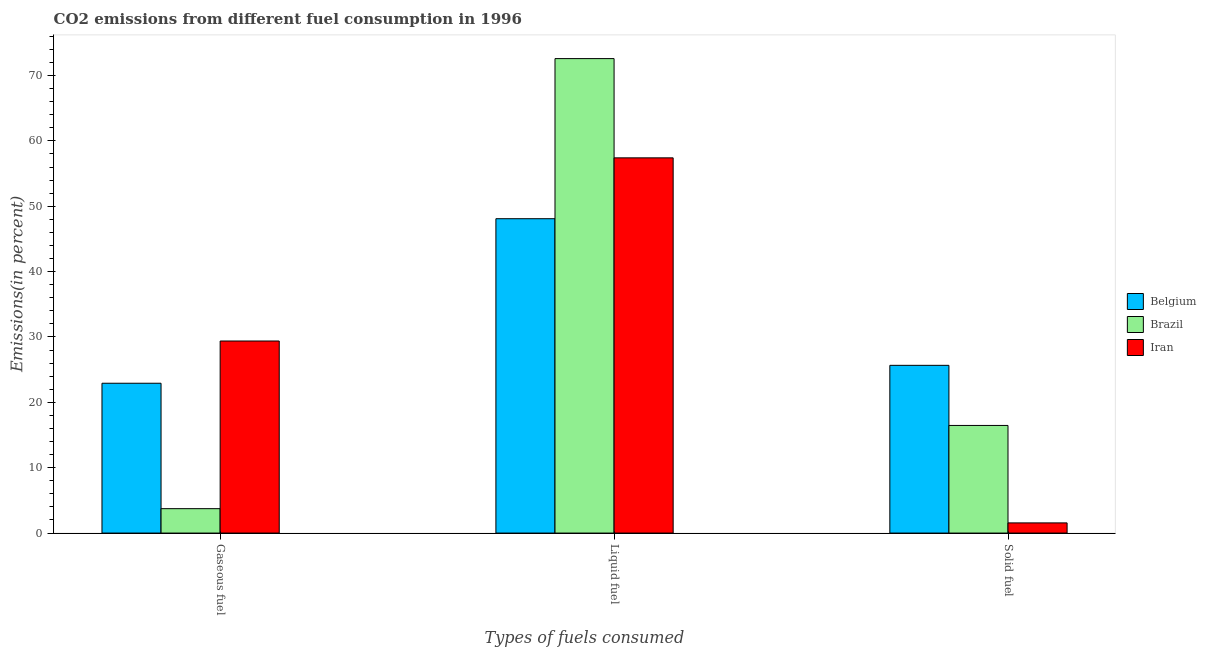How many different coloured bars are there?
Ensure brevity in your answer.  3. How many groups of bars are there?
Provide a succinct answer. 3. Are the number of bars on each tick of the X-axis equal?
Keep it short and to the point. Yes. How many bars are there on the 2nd tick from the left?
Ensure brevity in your answer.  3. What is the label of the 3rd group of bars from the left?
Ensure brevity in your answer.  Solid fuel. What is the percentage of solid fuel emission in Iran?
Offer a terse response. 1.56. Across all countries, what is the maximum percentage of solid fuel emission?
Provide a succinct answer. 25.66. Across all countries, what is the minimum percentage of gaseous fuel emission?
Provide a succinct answer. 3.73. In which country was the percentage of liquid fuel emission maximum?
Provide a short and direct response. Brazil. In which country was the percentage of solid fuel emission minimum?
Your answer should be very brief. Iran. What is the total percentage of liquid fuel emission in the graph?
Provide a short and direct response. 178.09. What is the difference between the percentage of solid fuel emission in Brazil and that in Belgium?
Give a very brief answer. -9.2. What is the difference between the percentage of gaseous fuel emission in Belgium and the percentage of liquid fuel emission in Brazil?
Make the answer very short. -49.67. What is the average percentage of liquid fuel emission per country?
Provide a succinct answer. 59.36. What is the difference between the percentage of gaseous fuel emission and percentage of liquid fuel emission in Brazil?
Provide a succinct answer. -68.86. In how many countries, is the percentage of gaseous fuel emission greater than 42 %?
Offer a terse response. 0. What is the ratio of the percentage of gaseous fuel emission in Brazil to that in Belgium?
Keep it short and to the point. 0.16. Is the percentage of liquid fuel emission in Belgium less than that in Brazil?
Ensure brevity in your answer.  Yes. Is the difference between the percentage of gaseous fuel emission in Brazil and Belgium greater than the difference between the percentage of liquid fuel emission in Brazil and Belgium?
Offer a very short reply. No. What is the difference between the highest and the second highest percentage of liquid fuel emission?
Offer a very short reply. 15.19. What is the difference between the highest and the lowest percentage of gaseous fuel emission?
Provide a succinct answer. 25.65. Is it the case that in every country, the sum of the percentage of gaseous fuel emission and percentage of liquid fuel emission is greater than the percentage of solid fuel emission?
Provide a short and direct response. Yes. How many countries are there in the graph?
Make the answer very short. 3. Are the values on the major ticks of Y-axis written in scientific E-notation?
Give a very brief answer. No. Where does the legend appear in the graph?
Offer a terse response. Center right. How many legend labels are there?
Provide a short and direct response. 3. How are the legend labels stacked?
Offer a terse response. Vertical. What is the title of the graph?
Your answer should be compact. CO2 emissions from different fuel consumption in 1996. Does "Latvia" appear as one of the legend labels in the graph?
Your answer should be compact. No. What is the label or title of the X-axis?
Keep it short and to the point. Types of fuels consumed. What is the label or title of the Y-axis?
Give a very brief answer. Emissions(in percent). What is the Emissions(in percent) of Belgium in Gaseous fuel?
Offer a very short reply. 22.92. What is the Emissions(in percent) in Brazil in Gaseous fuel?
Your response must be concise. 3.73. What is the Emissions(in percent) of Iran in Gaseous fuel?
Your answer should be very brief. 29.38. What is the Emissions(in percent) in Belgium in Liquid fuel?
Keep it short and to the point. 48.09. What is the Emissions(in percent) of Brazil in Liquid fuel?
Make the answer very short. 72.59. What is the Emissions(in percent) in Iran in Liquid fuel?
Provide a succinct answer. 57.4. What is the Emissions(in percent) of Belgium in Solid fuel?
Provide a succinct answer. 25.66. What is the Emissions(in percent) in Brazil in Solid fuel?
Offer a terse response. 16.47. What is the Emissions(in percent) of Iran in Solid fuel?
Your response must be concise. 1.56. Across all Types of fuels consumed, what is the maximum Emissions(in percent) in Belgium?
Your answer should be compact. 48.09. Across all Types of fuels consumed, what is the maximum Emissions(in percent) in Brazil?
Your answer should be very brief. 72.59. Across all Types of fuels consumed, what is the maximum Emissions(in percent) of Iran?
Keep it short and to the point. 57.4. Across all Types of fuels consumed, what is the minimum Emissions(in percent) of Belgium?
Your answer should be very brief. 22.92. Across all Types of fuels consumed, what is the minimum Emissions(in percent) of Brazil?
Provide a short and direct response. 3.73. Across all Types of fuels consumed, what is the minimum Emissions(in percent) of Iran?
Offer a terse response. 1.56. What is the total Emissions(in percent) in Belgium in the graph?
Provide a succinct answer. 96.68. What is the total Emissions(in percent) of Brazil in the graph?
Your answer should be compact. 92.79. What is the total Emissions(in percent) of Iran in the graph?
Provide a short and direct response. 88.34. What is the difference between the Emissions(in percent) in Belgium in Gaseous fuel and that in Liquid fuel?
Offer a very short reply. -25.17. What is the difference between the Emissions(in percent) of Brazil in Gaseous fuel and that in Liquid fuel?
Ensure brevity in your answer.  -68.86. What is the difference between the Emissions(in percent) of Iran in Gaseous fuel and that in Liquid fuel?
Your answer should be very brief. -28.02. What is the difference between the Emissions(in percent) of Belgium in Gaseous fuel and that in Solid fuel?
Give a very brief answer. -2.74. What is the difference between the Emissions(in percent) in Brazil in Gaseous fuel and that in Solid fuel?
Offer a very short reply. -12.73. What is the difference between the Emissions(in percent) of Iran in Gaseous fuel and that in Solid fuel?
Provide a short and direct response. 27.83. What is the difference between the Emissions(in percent) of Belgium in Liquid fuel and that in Solid fuel?
Offer a terse response. 22.43. What is the difference between the Emissions(in percent) of Brazil in Liquid fuel and that in Solid fuel?
Give a very brief answer. 56.12. What is the difference between the Emissions(in percent) in Iran in Liquid fuel and that in Solid fuel?
Offer a terse response. 55.85. What is the difference between the Emissions(in percent) in Belgium in Gaseous fuel and the Emissions(in percent) in Brazil in Liquid fuel?
Your answer should be very brief. -49.67. What is the difference between the Emissions(in percent) in Belgium in Gaseous fuel and the Emissions(in percent) in Iran in Liquid fuel?
Provide a succinct answer. -34.48. What is the difference between the Emissions(in percent) in Brazil in Gaseous fuel and the Emissions(in percent) in Iran in Liquid fuel?
Provide a short and direct response. -53.67. What is the difference between the Emissions(in percent) in Belgium in Gaseous fuel and the Emissions(in percent) in Brazil in Solid fuel?
Make the answer very short. 6.46. What is the difference between the Emissions(in percent) in Belgium in Gaseous fuel and the Emissions(in percent) in Iran in Solid fuel?
Your answer should be compact. 21.37. What is the difference between the Emissions(in percent) of Brazil in Gaseous fuel and the Emissions(in percent) of Iran in Solid fuel?
Keep it short and to the point. 2.18. What is the difference between the Emissions(in percent) of Belgium in Liquid fuel and the Emissions(in percent) of Brazil in Solid fuel?
Make the answer very short. 31.63. What is the difference between the Emissions(in percent) in Belgium in Liquid fuel and the Emissions(in percent) in Iran in Solid fuel?
Provide a succinct answer. 46.54. What is the difference between the Emissions(in percent) of Brazil in Liquid fuel and the Emissions(in percent) of Iran in Solid fuel?
Provide a short and direct response. 71.03. What is the average Emissions(in percent) of Belgium per Types of fuels consumed?
Your response must be concise. 32.23. What is the average Emissions(in percent) of Brazil per Types of fuels consumed?
Ensure brevity in your answer.  30.93. What is the average Emissions(in percent) of Iran per Types of fuels consumed?
Your answer should be very brief. 29.45. What is the difference between the Emissions(in percent) in Belgium and Emissions(in percent) in Brazil in Gaseous fuel?
Your response must be concise. 19.19. What is the difference between the Emissions(in percent) of Belgium and Emissions(in percent) of Iran in Gaseous fuel?
Provide a short and direct response. -6.46. What is the difference between the Emissions(in percent) of Brazil and Emissions(in percent) of Iran in Gaseous fuel?
Offer a very short reply. -25.65. What is the difference between the Emissions(in percent) of Belgium and Emissions(in percent) of Brazil in Liquid fuel?
Your answer should be compact. -24.49. What is the difference between the Emissions(in percent) of Belgium and Emissions(in percent) of Iran in Liquid fuel?
Give a very brief answer. -9.31. What is the difference between the Emissions(in percent) in Brazil and Emissions(in percent) in Iran in Liquid fuel?
Provide a succinct answer. 15.19. What is the difference between the Emissions(in percent) of Belgium and Emissions(in percent) of Brazil in Solid fuel?
Provide a short and direct response. 9.2. What is the difference between the Emissions(in percent) in Belgium and Emissions(in percent) in Iran in Solid fuel?
Provide a succinct answer. 24.11. What is the difference between the Emissions(in percent) in Brazil and Emissions(in percent) in Iran in Solid fuel?
Ensure brevity in your answer.  14.91. What is the ratio of the Emissions(in percent) of Belgium in Gaseous fuel to that in Liquid fuel?
Offer a very short reply. 0.48. What is the ratio of the Emissions(in percent) in Brazil in Gaseous fuel to that in Liquid fuel?
Your answer should be compact. 0.05. What is the ratio of the Emissions(in percent) of Iran in Gaseous fuel to that in Liquid fuel?
Ensure brevity in your answer.  0.51. What is the ratio of the Emissions(in percent) of Belgium in Gaseous fuel to that in Solid fuel?
Your answer should be very brief. 0.89. What is the ratio of the Emissions(in percent) in Brazil in Gaseous fuel to that in Solid fuel?
Keep it short and to the point. 0.23. What is the ratio of the Emissions(in percent) of Iran in Gaseous fuel to that in Solid fuel?
Your answer should be very brief. 18.89. What is the ratio of the Emissions(in percent) in Belgium in Liquid fuel to that in Solid fuel?
Give a very brief answer. 1.87. What is the ratio of the Emissions(in percent) in Brazil in Liquid fuel to that in Solid fuel?
Your answer should be very brief. 4.41. What is the ratio of the Emissions(in percent) in Iran in Liquid fuel to that in Solid fuel?
Keep it short and to the point. 36.9. What is the difference between the highest and the second highest Emissions(in percent) of Belgium?
Provide a short and direct response. 22.43. What is the difference between the highest and the second highest Emissions(in percent) in Brazil?
Your response must be concise. 56.12. What is the difference between the highest and the second highest Emissions(in percent) in Iran?
Provide a succinct answer. 28.02. What is the difference between the highest and the lowest Emissions(in percent) of Belgium?
Make the answer very short. 25.17. What is the difference between the highest and the lowest Emissions(in percent) of Brazil?
Make the answer very short. 68.86. What is the difference between the highest and the lowest Emissions(in percent) of Iran?
Offer a terse response. 55.85. 